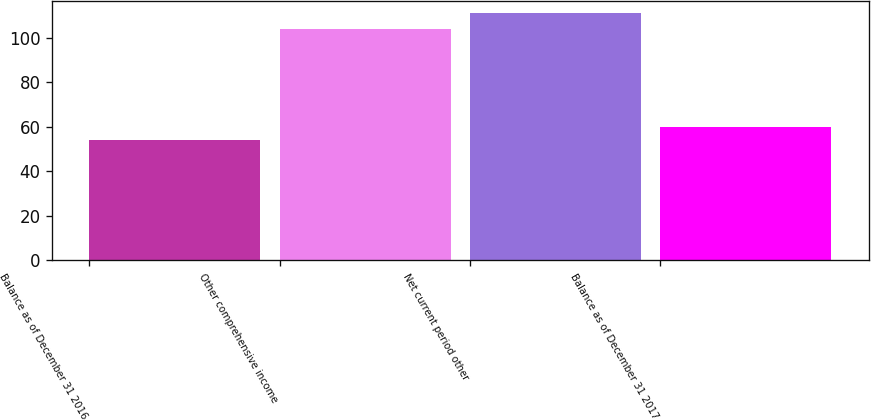Convert chart. <chart><loc_0><loc_0><loc_500><loc_500><bar_chart><fcel>Balance as of December 31 2016<fcel>Other comprehensive income<fcel>Net current period other<fcel>Balance as of December 31 2017<nl><fcel>54<fcel>104<fcel>111<fcel>59.7<nl></chart> 